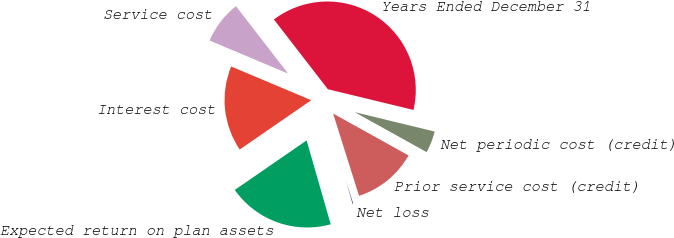Convert chart. <chart><loc_0><loc_0><loc_500><loc_500><pie_chart><fcel>Years Ended December 31<fcel>Service cost<fcel>Interest cost<fcel>Expected return on plan assets<fcel>Net loss<fcel>Prior service cost (credit)<fcel>Net periodic cost (credit)<nl><fcel>39.26%<fcel>8.18%<fcel>15.95%<fcel>19.84%<fcel>0.41%<fcel>12.07%<fcel>4.29%<nl></chart> 